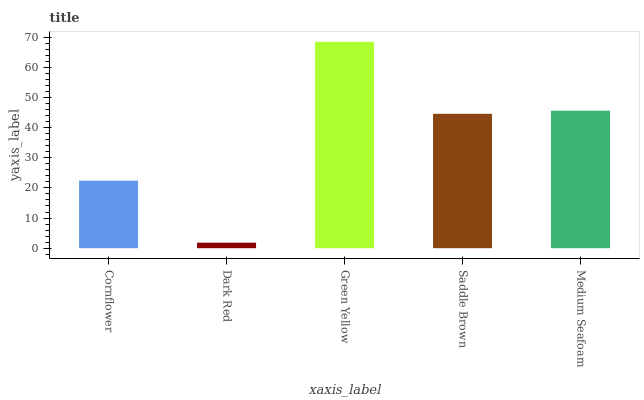Is Dark Red the minimum?
Answer yes or no. Yes. Is Green Yellow the maximum?
Answer yes or no. Yes. Is Green Yellow the minimum?
Answer yes or no. No. Is Dark Red the maximum?
Answer yes or no. No. Is Green Yellow greater than Dark Red?
Answer yes or no. Yes. Is Dark Red less than Green Yellow?
Answer yes or no. Yes. Is Dark Red greater than Green Yellow?
Answer yes or no. No. Is Green Yellow less than Dark Red?
Answer yes or no. No. Is Saddle Brown the high median?
Answer yes or no. Yes. Is Saddle Brown the low median?
Answer yes or no. Yes. Is Medium Seafoam the high median?
Answer yes or no. No. Is Medium Seafoam the low median?
Answer yes or no. No. 